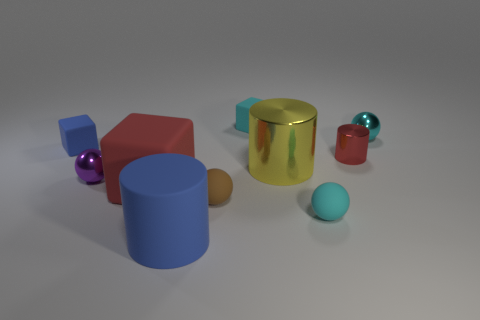Subtract 1 spheres. How many spheres are left? 3 Subtract all spheres. How many objects are left? 6 Add 3 yellow shiny objects. How many yellow shiny objects exist? 4 Subtract 0 brown cylinders. How many objects are left? 10 Subtract all brown rubber cylinders. Subtract all small blue blocks. How many objects are left? 9 Add 8 yellow cylinders. How many yellow cylinders are left? 9 